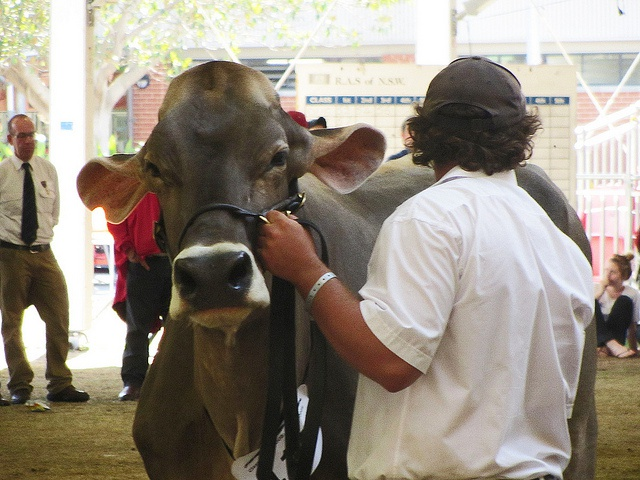Describe the objects in this image and their specific colors. I can see cow in lightgreen, black, gray, and maroon tones, people in lightgreen, darkgray, lightgray, black, and maroon tones, people in lightgreen, black, tan, and gray tones, people in lightgreen, black, brown, and maroon tones, and people in lightgreen, black, tan, darkgray, and maroon tones in this image. 